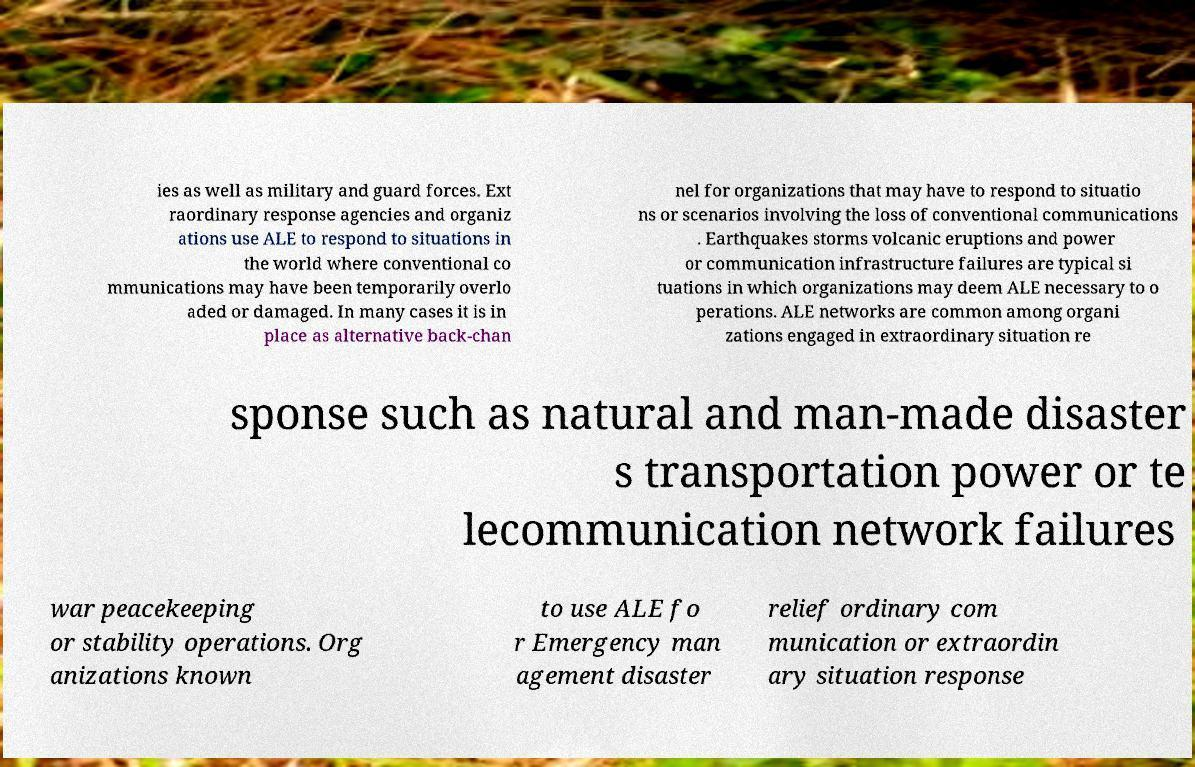Can you accurately transcribe the text from the provided image for me? ies as well as military and guard forces. Ext raordinary response agencies and organiz ations use ALE to respond to situations in the world where conventional co mmunications may have been temporarily overlo aded or damaged. In many cases it is in place as alternative back-chan nel for organizations that may have to respond to situatio ns or scenarios involving the loss of conventional communications . Earthquakes storms volcanic eruptions and power or communication infrastructure failures are typical si tuations in which organizations may deem ALE necessary to o perations. ALE networks are common among organi zations engaged in extraordinary situation re sponse such as natural and man-made disaster s transportation power or te lecommunication network failures war peacekeeping or stability operations. Org anizations known to use ALE fo r Emergency man agement disaster relief ordinary com munication or extraordin ary situation response 